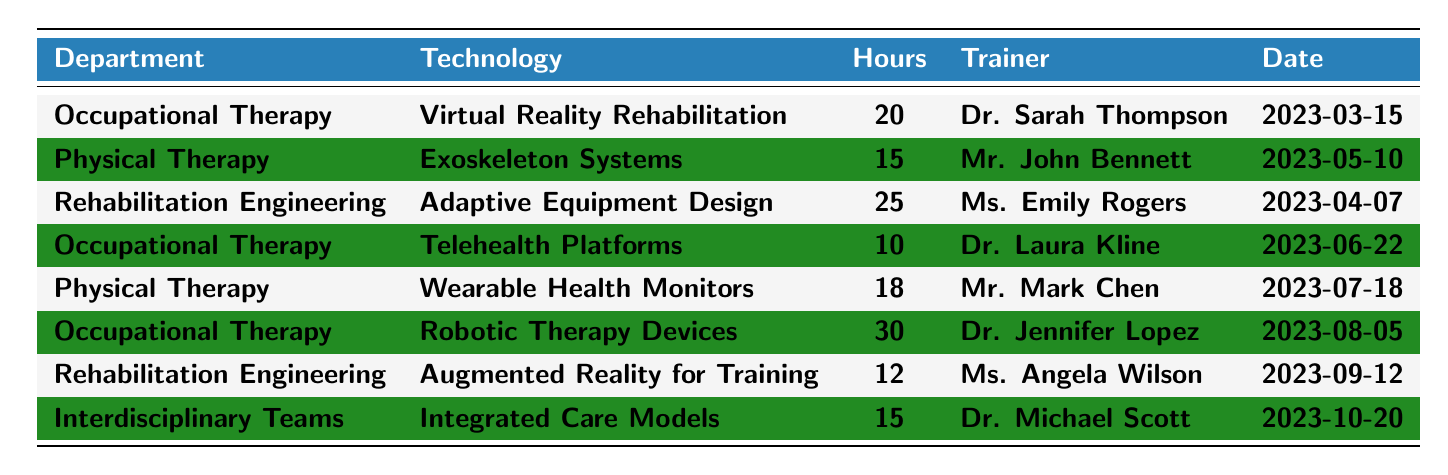What is the total number of training hours provided to the Occupational Therapy department? The Occupational Therapy department has three training events listed: 20 hours for Virtual Reality Rehabilitation, 10 hours for Telehealth Platforms, and 30 hours for Robotic Therapy Devices. Adding these gives 20 + 10 + 30 = 60 hours.
Answer: 60 hours Who was the trainer for the Adaptive Equipment Design technology? The Adaptive Equipment Design technology in the Rehabilitation Engineering department was trained by Ms. Emily Rogers.
Answer: Ms. Emily Rogers What is the average number of training hours provided across all departments? There are a total of 8 training events: 20, 15, 25, 10, 18, 30, 12, and 15 hours. The sum of these hours is 20 + 15 + 25 + 10 + 18 + 30 + 12 + 15 = 145 hours. There are 8 events, then the average is 145 / 8 = 18.125 hours.
Answer: 18.125 hours Does the Physical Therapy department have more training hours than the Rehabilitation Engineering department? The Physical Therapy department has two training hours: 15 for Exoskeleton Systems and 18 for Wearable Health Monitors, totaling 33 hours. The Rehabilitation Engineering department has a total of 25 hours for Adaptive Equipment Design and 12 hours for Augmented Reality for Training, totaling 37 hours. Since 33 is less than 37, the statement is false.
Answer: No Which technology had the highest number of training hours, and what is that amount? By reviewing the table, the highest number of training hours is for Robotic Therapy Devices at 30 hours.
Answer: Robotic Therapy Devices, 30 hours How many different trainers conducted sessions in the table? There are 6 unique trainers listed: Dr. Sarah Thompson, Mr. John Bennett, Ms. Emily Rogers, Dr. Laura Kline, Mr. Mark Chen, Dr. Jennifer Lopez, Ms. Angela Wilson, and Dr. Michael Scott. Counting these gives a total of 8 trainers.
Answer: 8 trainers What percentage of the total training hours was dedicated to Occupational Therapy? The total training hours are 145. Occupational Therapy hours are 60, which is (60 / 145) * 100 = 41.38%.
Answer: 41.38% Which department received training on Telehealth Platforms, and how many hours were provided? The training on Telehealth Platforms was provided to the Occupational Therapy department, and it consisted of 10 hours.
Answer: Occupational Therapy, 10 hours Which department had the least training hours, and what was the technology involved? The least training hours listed are 10 hours for the technology of Telehealth Platforms provided to the Occupational Therapy department.
Answer: Occupational Therapy, Telehealth Platforms, 10 hours 